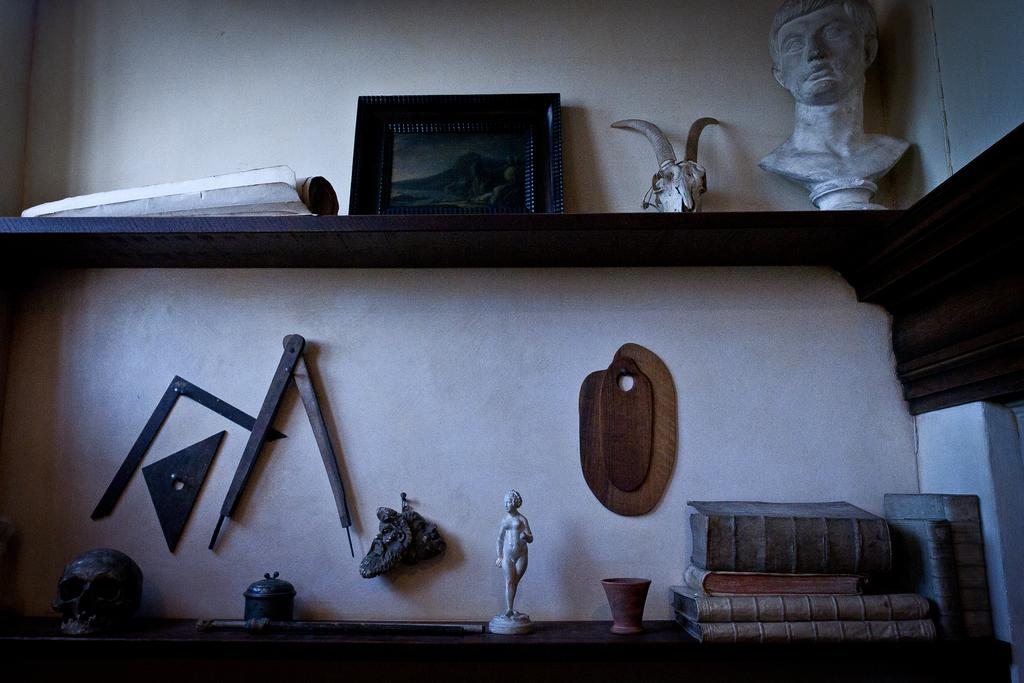What type of object can be seen in the image that typically holds photos? There is a photo frame in the image. What type of artistic objects can be seen in the image? There are sculptures in the image. What type of objects can be seen in the image that are used for reading and learning? There are books in the image. What type of object can be seen in the image that is associated with death? There is a skull in the image. What type of storage system can be seen in the image? There are objects placed in racks in the image. What type of objects can be seen in the image that are attached to the wall? There are objects attached to the wall in the image. Can you tell me how many suns are visible in the image? There are no suns visible in the image. What type of branch can be seen growing from the skull in the image? There is no branch growing from the skull in the image; there is only a skull present. 